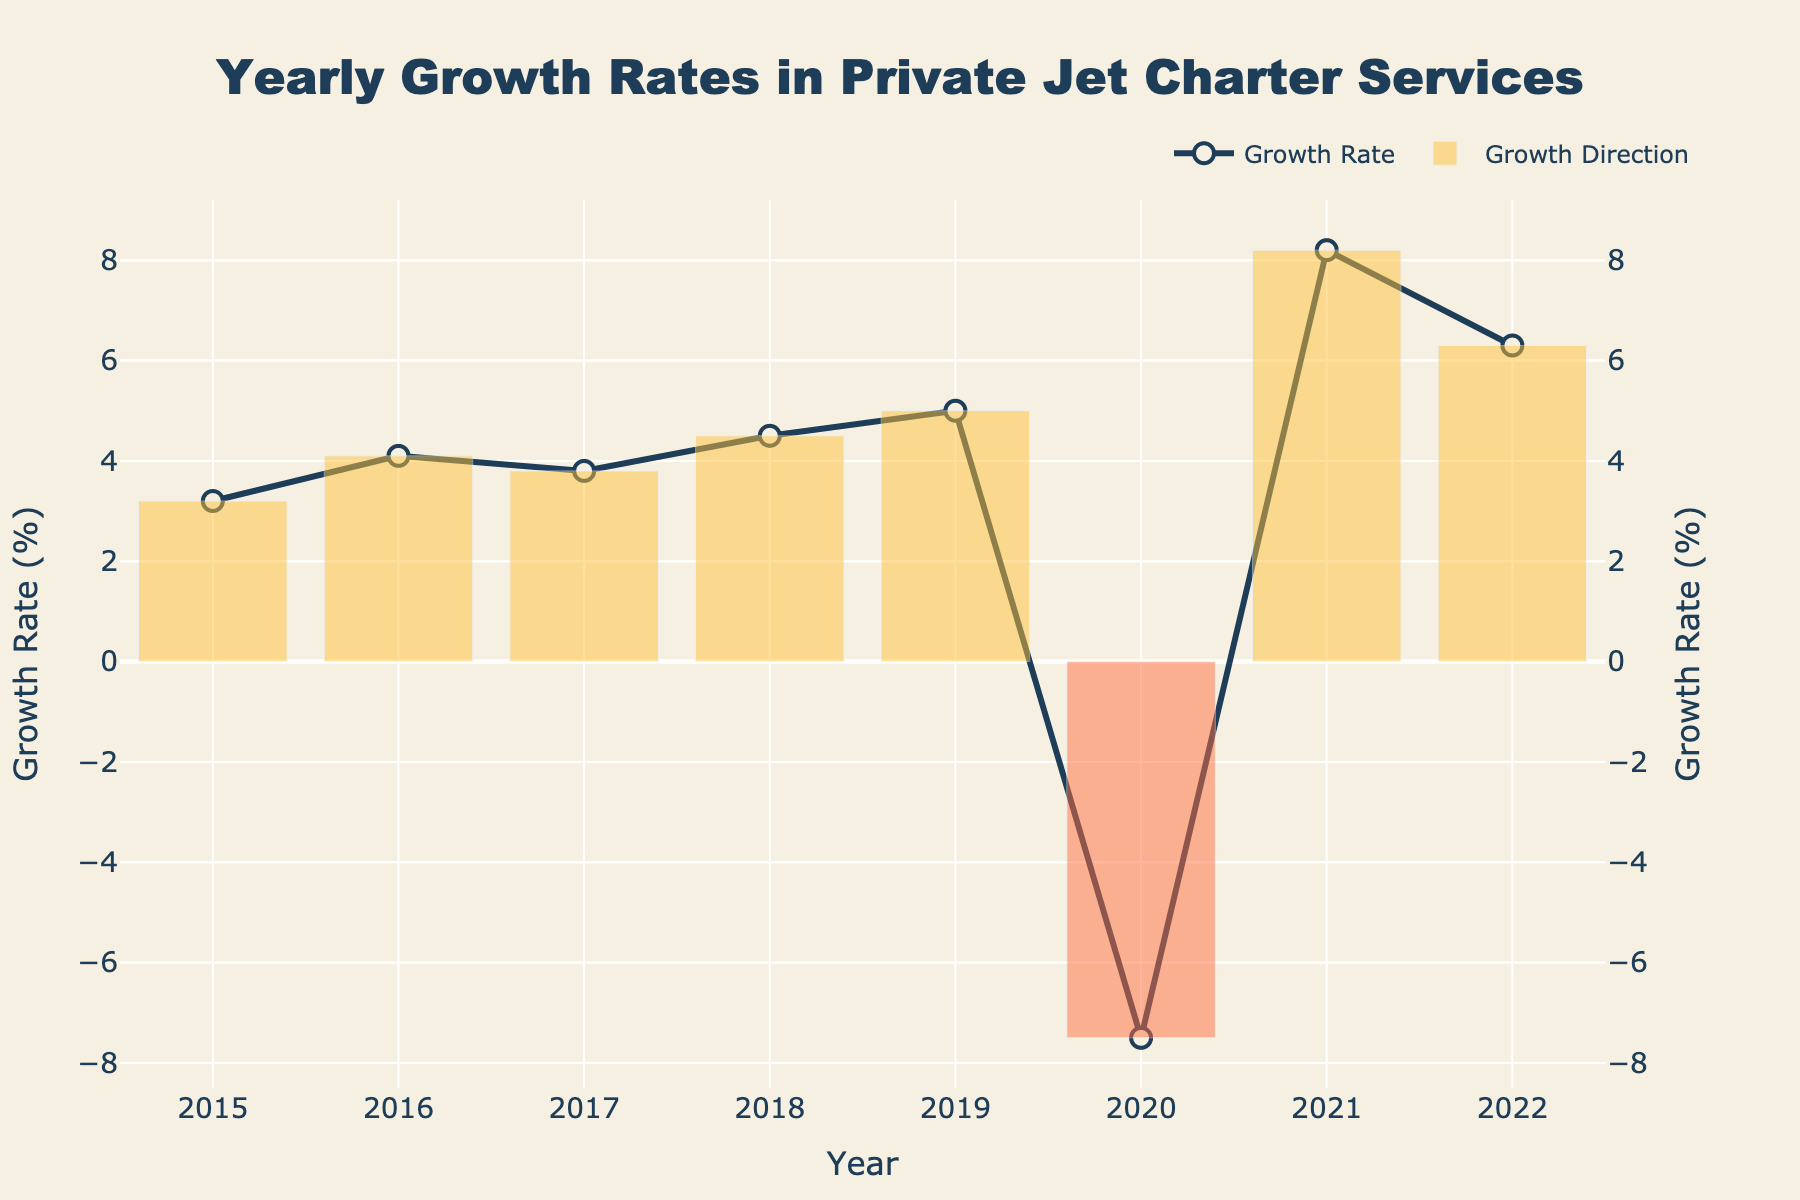What is the title of the figure? The title is usually found at the top of the figure. Here, it reads "Yearly Growth Rates in Private Jet Charter Services".
Answer: Yearly Growth Rates in Private Jet Charter Services How many data points are in the figure? Each data point corresponds to a year from 2015 to 2022. Counting these years gives us a total of 8 data points.
Answer: 8 Which year experienced the lowest growth rate, and what was the value? Observing the y-axis values, the lowest point in the data is in 2020 with a growth rate of -7.5%.
Answer: 2020, -7.5% What were the positive growth rates from 2015 to 2019? Extracting the values from these years, we get the following rates: 2015: 3.2%, 2016: 4.1%, 2017: 3.8%, 2018: 4.5%, and 2019: 5.0%.
Answer: 3.2%, 4.1%, 3.8%, 4.5%, 5.0% What is the difference in the growth rates between 2021 and 2022? To find the difference, subtract the 2022 growth rate from the 2021 growth rate: 8.2% - 6.3% = 1.9%.
Answer: 1.9% How many years had a negative growth rate, and which are they? From the y-axis values, we observe that only 2020 had a negative growth rate, at -7.5%.
Answer: 1 year, 2020 What is the average growth rate over the years 2019, 2021, and 2022? Summing the growth rates: 5.0% + 8.2% + 6.3% = 19.5%. Dividing by 3 gives us the average: 19.5% / 3 = 6.5%.
Answer: 6.5% How did the growth rate change from 2019 to 2020? The growth rate went from 5.0% in 2019 to -7.5% in 2020. The difference is 5.0% - (-7.5%) = 12.5%.
Answer: Decreased by 12.5% Which year had the highest growth rate, and what was the value? Observing the y-axis values, the highest growth rate occurred in 2021 with a value of 8.2%.
Answer: 2021, 8.2% How many years had growth rates higher than 4%? From the years observed: 2016 (4.1%), 2018 (4.5%), 2019 (5.0%), 2021 (8.2%), and 2022 (6.3%). There are 5 such years.
Answer: 5 